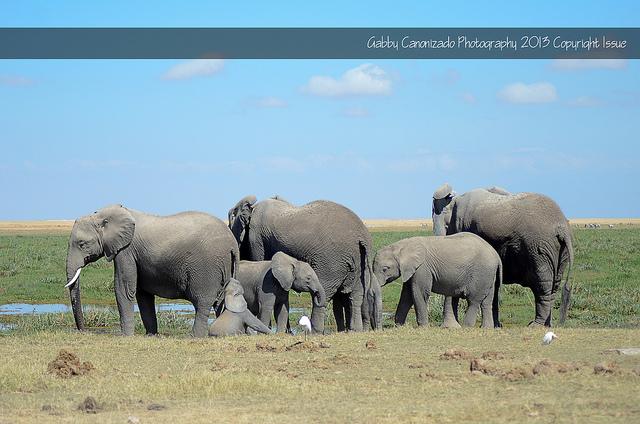Are the elephants thirsty?
Give a very brief answer. No. Are there clouds in the sky?
Concise answer only. Yes. Are these all adult animals?
Quick response, please. No. How many tusks are visible?
Give a very brief answer. 1. What animals are photographed?
Write a very short answer. Elephants. What are the animals in the picture?
Be succinct. Elephants. What are the elephants standing in?
Concise answer only. Grass. 